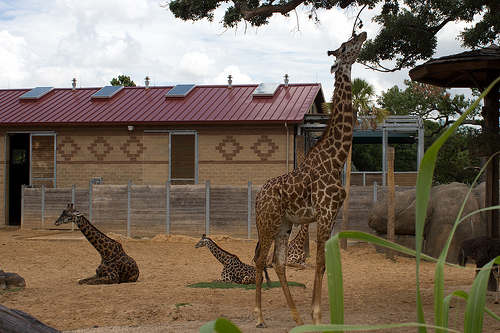Please provide the bounding box coordinate of the region this sentence describes: The dirt is light brown. The coordinates identifying the region where the dirt appears light brown are [0.09, 0.73, 0.16, 0.81]. 